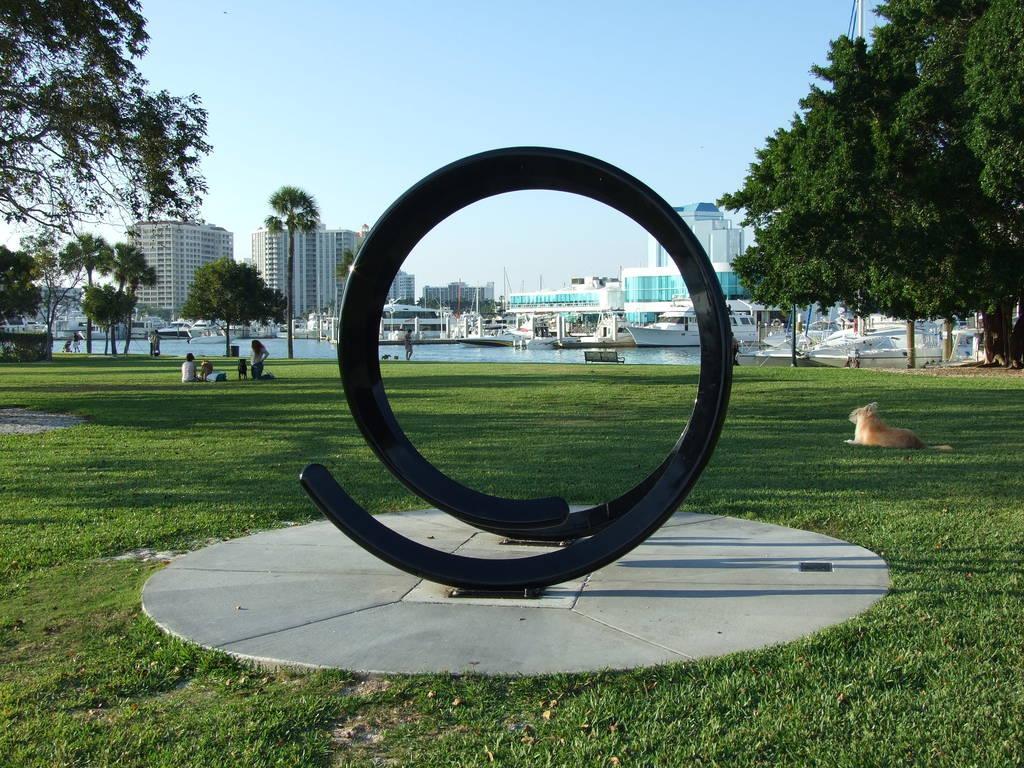Could you give a brief overview of what you see in this image? In this image we can see many buildings, there are boats in the water, there are trees, there is a pole, there are persons sitting on the ground, there is an animal on the grass, in front there is a sculpture, there is a sky. 